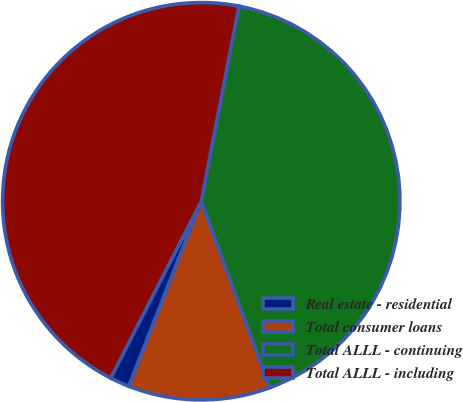<chart> <loc_0><loc_0><loc_500><loc_500><pie_chart><fcel>Real estate - residential<fcel>Total consumer loans<fcel>Total ALLL - continuing<fcel>Total ALLL - including<nl><fcel>1.6%<fcel>11.53%<fcel>41.36%<fcel>45.5%<nl></chart> 